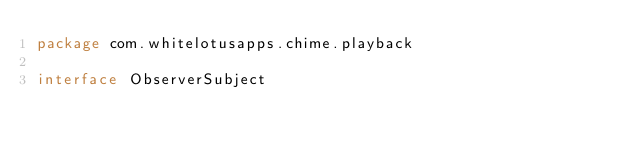Convert code to text. <code><loc_0><loc_0><loc_500><loc_500><_Kotlin_>package com.whitelotusapps.chime.playback

interface ObserverSubject </code> 